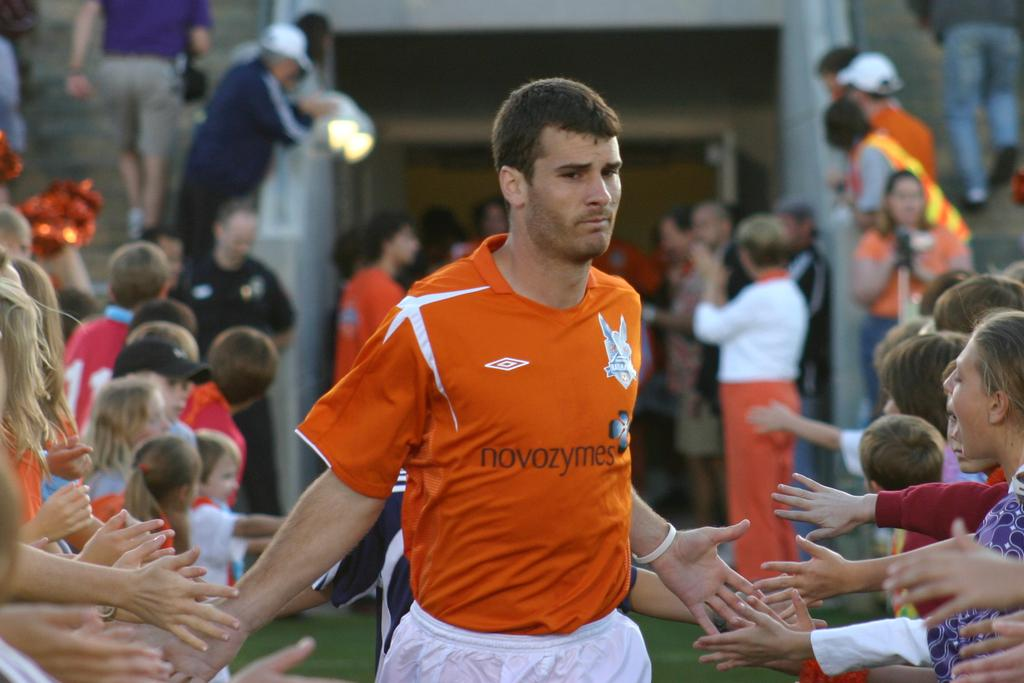Provide a one-sentence caption for the provided image. Professional soccer player wearing an orange noveozymese shirt palms fans with both his hands before going onto the playing field. 